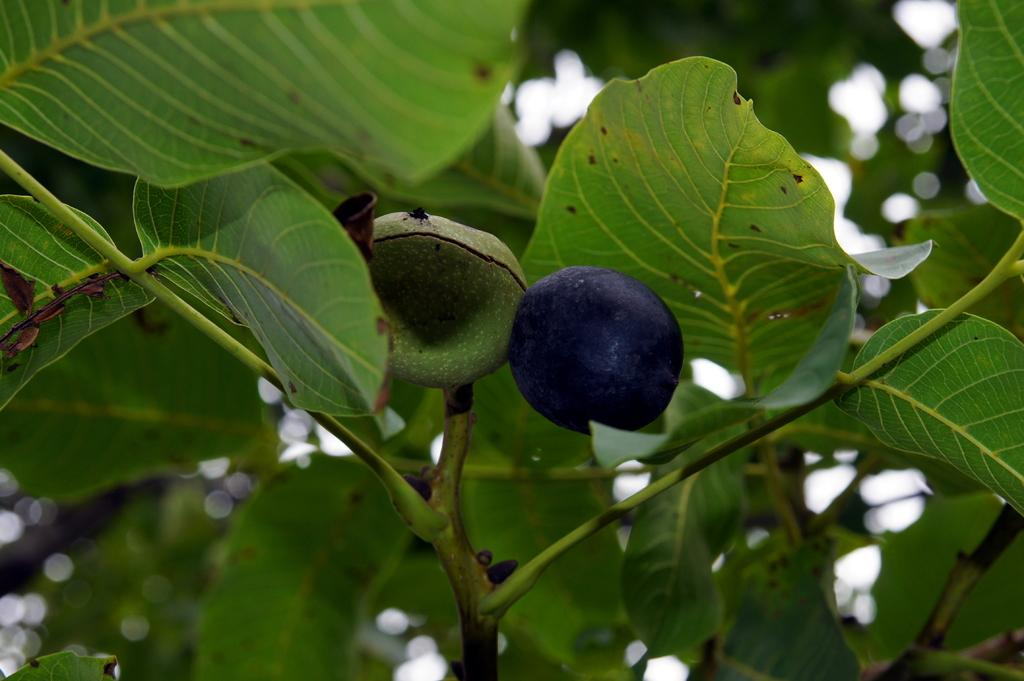What type of fruit is visible on a plant in the image? There is a berry on a plant in the image. What else can be seen in the background of the image? There are plants visible in the background of the image. What type of machine is used to create shade in the image? There is no machine present in the image, and therefore no such device is used to create shade. 